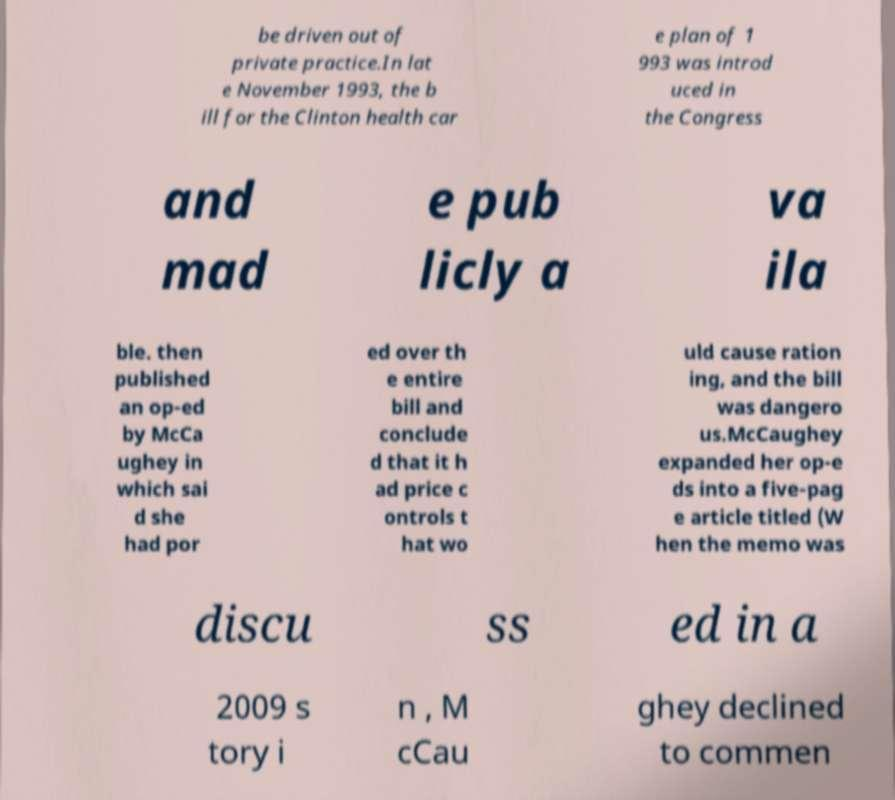Please read and relay the text visible in this image. What does it say? be driven out of private practice.In lat e November 1993, the b ill for the Clinton health car e plan of 1 993 was introd uced in the Congress and mad e pub licly a va ila ble. then published an op-ed by McCa ughey in which sai d she had por ed over th e entire bill and conclude d that it h ad price c ontrols t hat wo uld cause ration ing, and the bill was dangero us.McCaughey expanded her op-e ds into a five-pag e article titled (W hen the memo was discu ss ed in a 2009 s tory i n , M cCau ghey declined to commen 